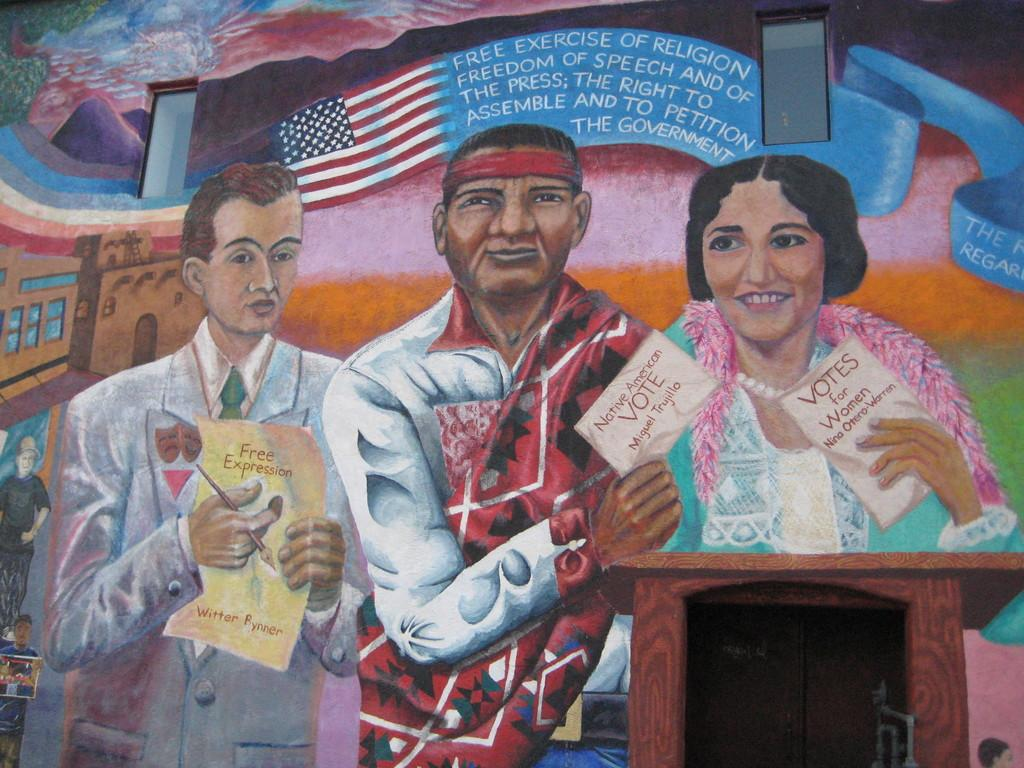What is the main subject of the image? There is a painting in the image. What is depicted in the painting? The painting depicts three people. What are the people doing in the painting? The people are standing in front of a podium. What are the people holding in their hands? The people are holding paper in their hands. What can be seen in the background of the painting? There is a US flag in the background of the painting. What type of pest can be seen crawling on the podium in the image? There are no pests visible in the image; the painting only depicts three people standing in front of a podium. How many bricks are used to construct the podium in the image? The painting does not provide information about the construction of the podium, so it is impossible to determine the number of bricks used. 